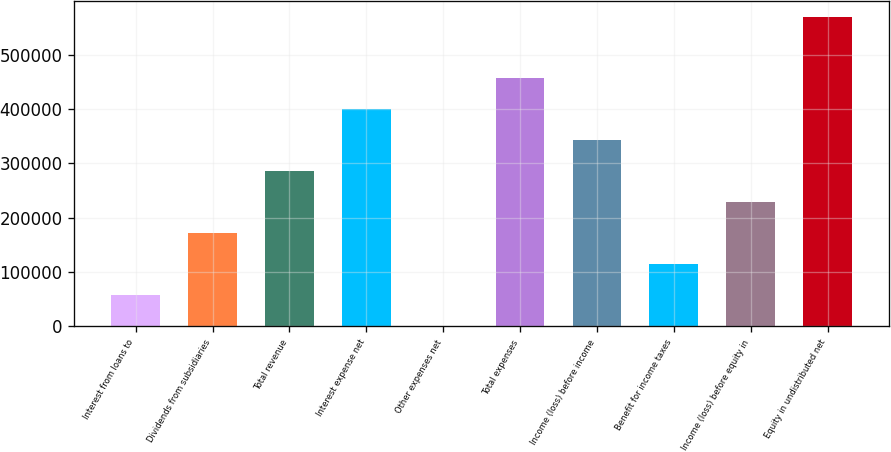<chart> <loc_0><loc_0><loc_500><loc_500><bar_chart><fcel>Interest from loans to<fcel>Dividends from subsidiaries<fcel>Total revenue<fcel>Interest expense net<fcel>Other expenses net<fcel>Total expenses<fcel>Income (loss) before income<fcel>Benefit for income taxes<fcel>Income (loss) before equity in<fcel>Equity in undistributed net<nl><fcel>58177.9<fcel>172054<fcel>285930<fcel>399805<fcel>1240<fcel>456743<fcel>342867<fcel>115116<fcel>228992<fcel>570619<nl></chart> 